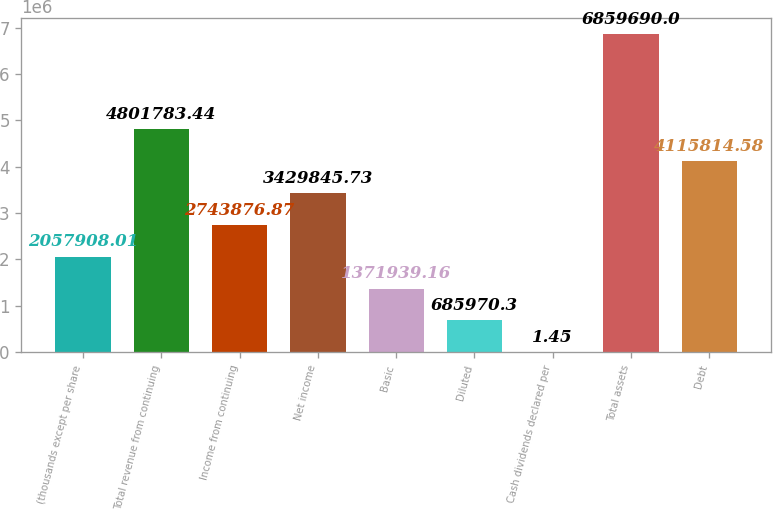Convert chart to OTSL. <chart><loc_0><loc_0><loc_500><loc_500><bar_chart><fcel>(thousands except per share<fcel>Total revenue from continuing<fcel>Income from continuing<fcel>Net income<fcel>Basic<fcel>Diluted<fcel>Cash dividends declared per<fcel>Total assets<fcel>Debt<nl><fcel>2.05791e+06<fcel>4.80178e+06<fcel>2.74388e+06<fcel>3.42985e+06<fcel>1.37194e+06<fcel>685970<fcel>1.45<fcel>6.85969e+06<fcel>4.11581e+06<nl></chart> 